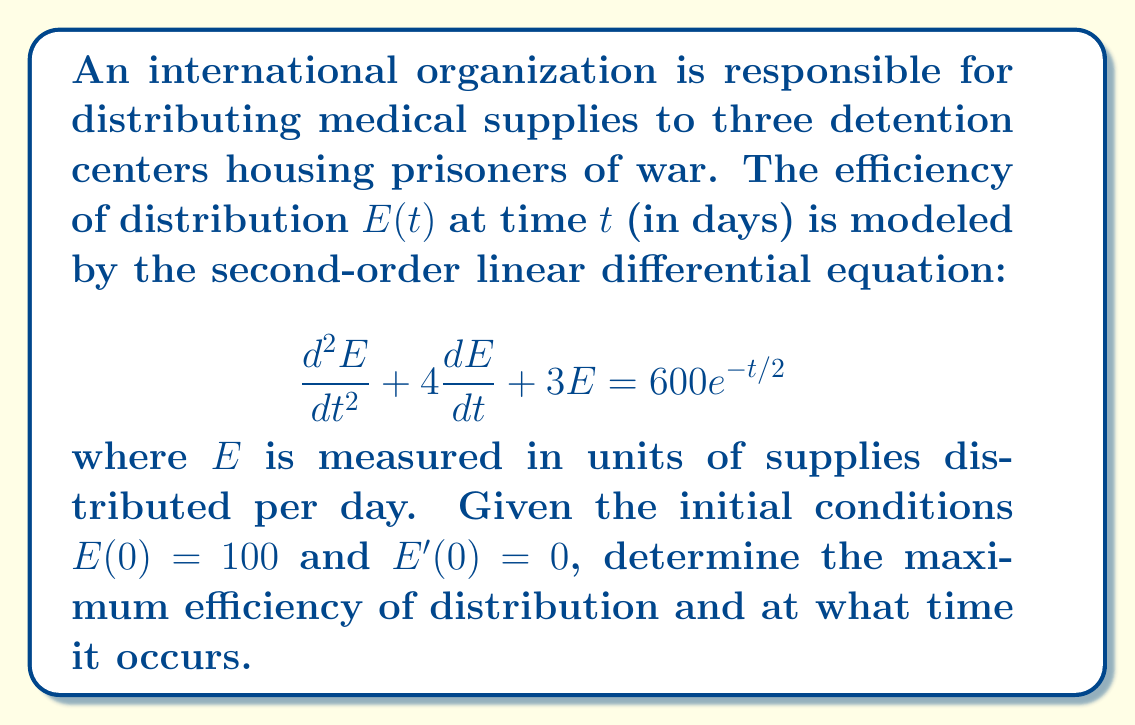Teach me how to tackle this problem. To solve this problem, we follow these steps:

1) The general solution to this equation is the sum of the complementary function and the particular integral:

   $E(t) = E_c(t) + E_p(t)$

2) For the complementary function, we solve the characteristic equation:
   $r^2 + 4r + 3 = 0$
   $(r + 1)(r + 3) = 0$
   $r = -1$ or $r = -3$

   So, $E_c(t) = Ae^{-t} + Be^{-3t}$

3) For the particular integral, we assume a solution of the form:
   $E_p(t) = Ce^{-t/2}$

   Substituting this into the original equation:
   $\frac{1}{4}Ce^{-t/2} - 2Ce^{-t/2} + 3Ce^{-t/2} = 600e^{-t/2}$
   $\frac{5}{4}Ce^{-t/2} = 600e^{-t/2}$
   $C = 480$

   So, $E_p(t) = 480e^{-t/2}$

4) The general solution is:
   $E(t) = Ae^{-t} + Be^{-3t} + 480e^{-t/2}$

5) Using the initial conditions:
   $E(0) = 100$: $A + B + 480 = 100$
   $E'(0) = 0$: $-A - 3B - 240 = 0$

   Solving these simultaneously:
   $A = -140$, $B = -240$

6) Therefore, the particular solution is:
   $E(t) = -140e^{-t} - 240e^{-3t} + 480e^{-t/2}$

7) To find the maximum, we differentiate and set to zero:
   $E'(t) = 140e^{-t} + 720e^{-3t} - 240e^{-t/2} = 0$

8) This equation can't be solved algebraically. Using numerical methods, we find that $E'(t) = 0$ when $t \approx 0.9205$ days.

9) The maximum efficiency is:
   $E(0.9205) \approx 137.8$ supplies per day
Answer: Maximum efficiency: 137.8 supplies/day at t ≈ 0.9205 days 